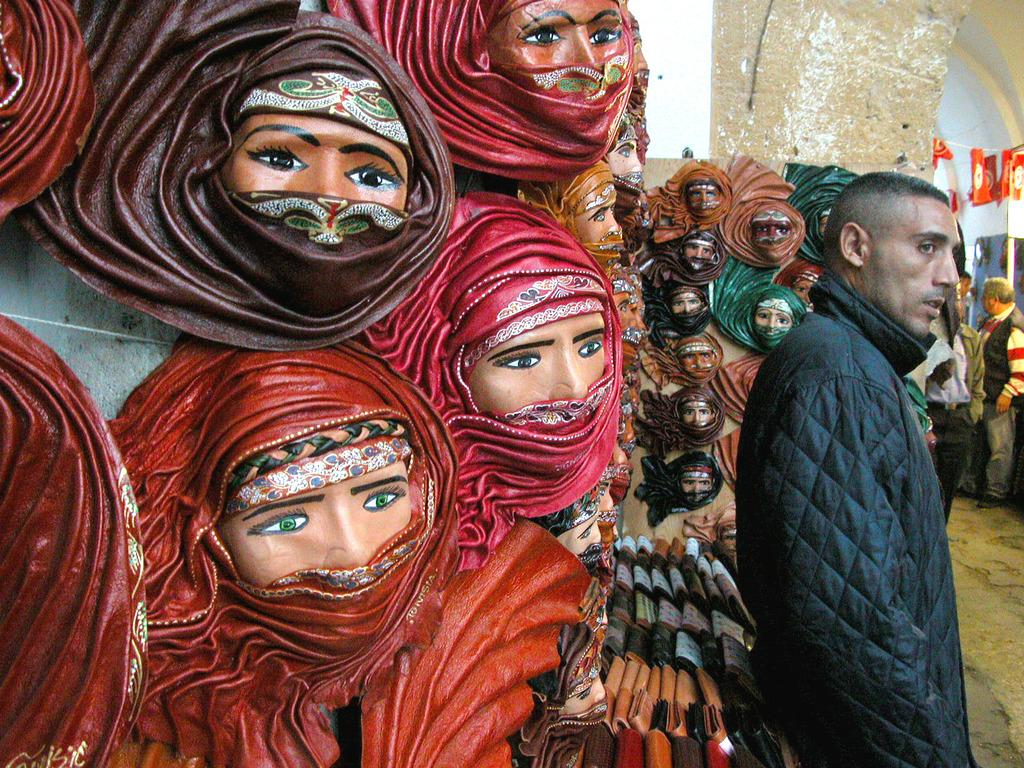What is the main subject in the image? There is a man standing in the image. What can be seen in the foreground area of the image? There are sculptures in the foreground area of the image. What is visible in the background of the image? There are people and some objects in the background of the image. How many chickens are visible in the image? There are no chickens present in the image. What type of debt is being discussed in the image? There is no mention of debt in the image. 